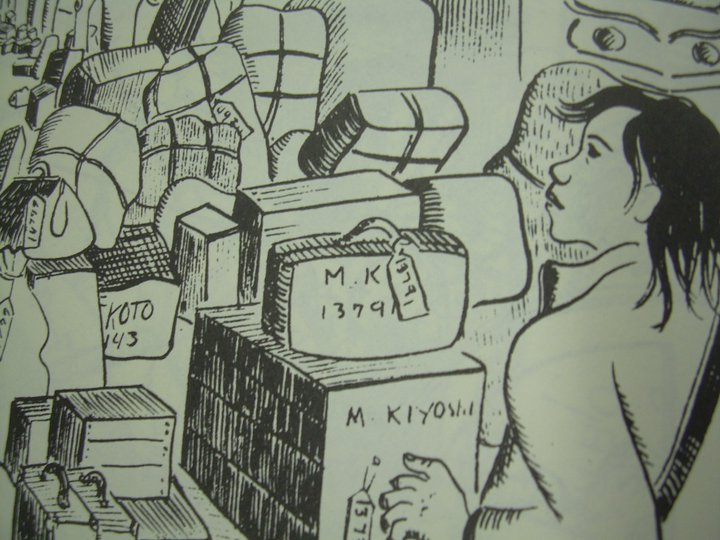What might be the significance of the labels seen in the image, particularly 'KYOTO 43'? The label 'KYOTO 43' likely refers to the year 1943, a period during World War II. Kyoto, being a city rich in cultural and historical significance in Japan, might imply that the belongings are relics from that tumultuous period, possibly evacuated or preserved amid wartime threats. This label might suggest the woman's connection or heritage, linking her personally to historical events or locations that have affected her life or that of her family. 